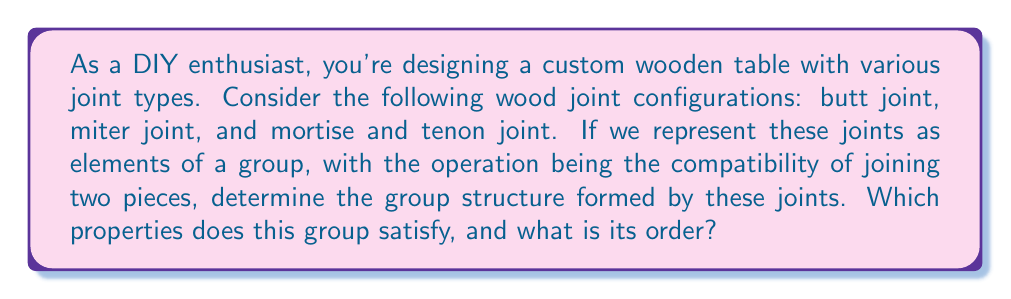What is the answer to this math problem? Let's approach this step-by-step using group theory:

1) First, let's define our set of elements:
   B: Butt joint
   M: Miter joint
   T: Mortise and tenon joint

2) The operation in this group is the compatibility of joining two pieces. We need to consider which joints can be combined with each other.

3) Let's create an operation table:

   $$
   \begin{array}{c|ccc}
   * & B & M & T \\
   \hline
   B & B & B & B \\
   M & B & M & B \\
   T & B & B & T
   \end{array}
   $$

4) Analyzing the table:
   - The operation is closed, as all results are within the set {B, M, T}.
   - B acts as the identity element, as B * X = X * B = X for all X.
   - Each element is its own inverse: X * X = B for all X.
   - The operation is associative (can be verified, though not shown in the table).

5) These properties satisfy all group axioms, so this forms a valid group.

6) The order of the group is the number of elements, which is 3.

7) This group structure is isomorphic to the cyclic group $C_3$ or $\mathbb{Z}_3$.
Answer: The wood joint configurations form a group of order 3, isomorphic to $C_3$ or $\mathbb{Z}_3$, satisfying closure, associativity, identity, and inverse properties. 